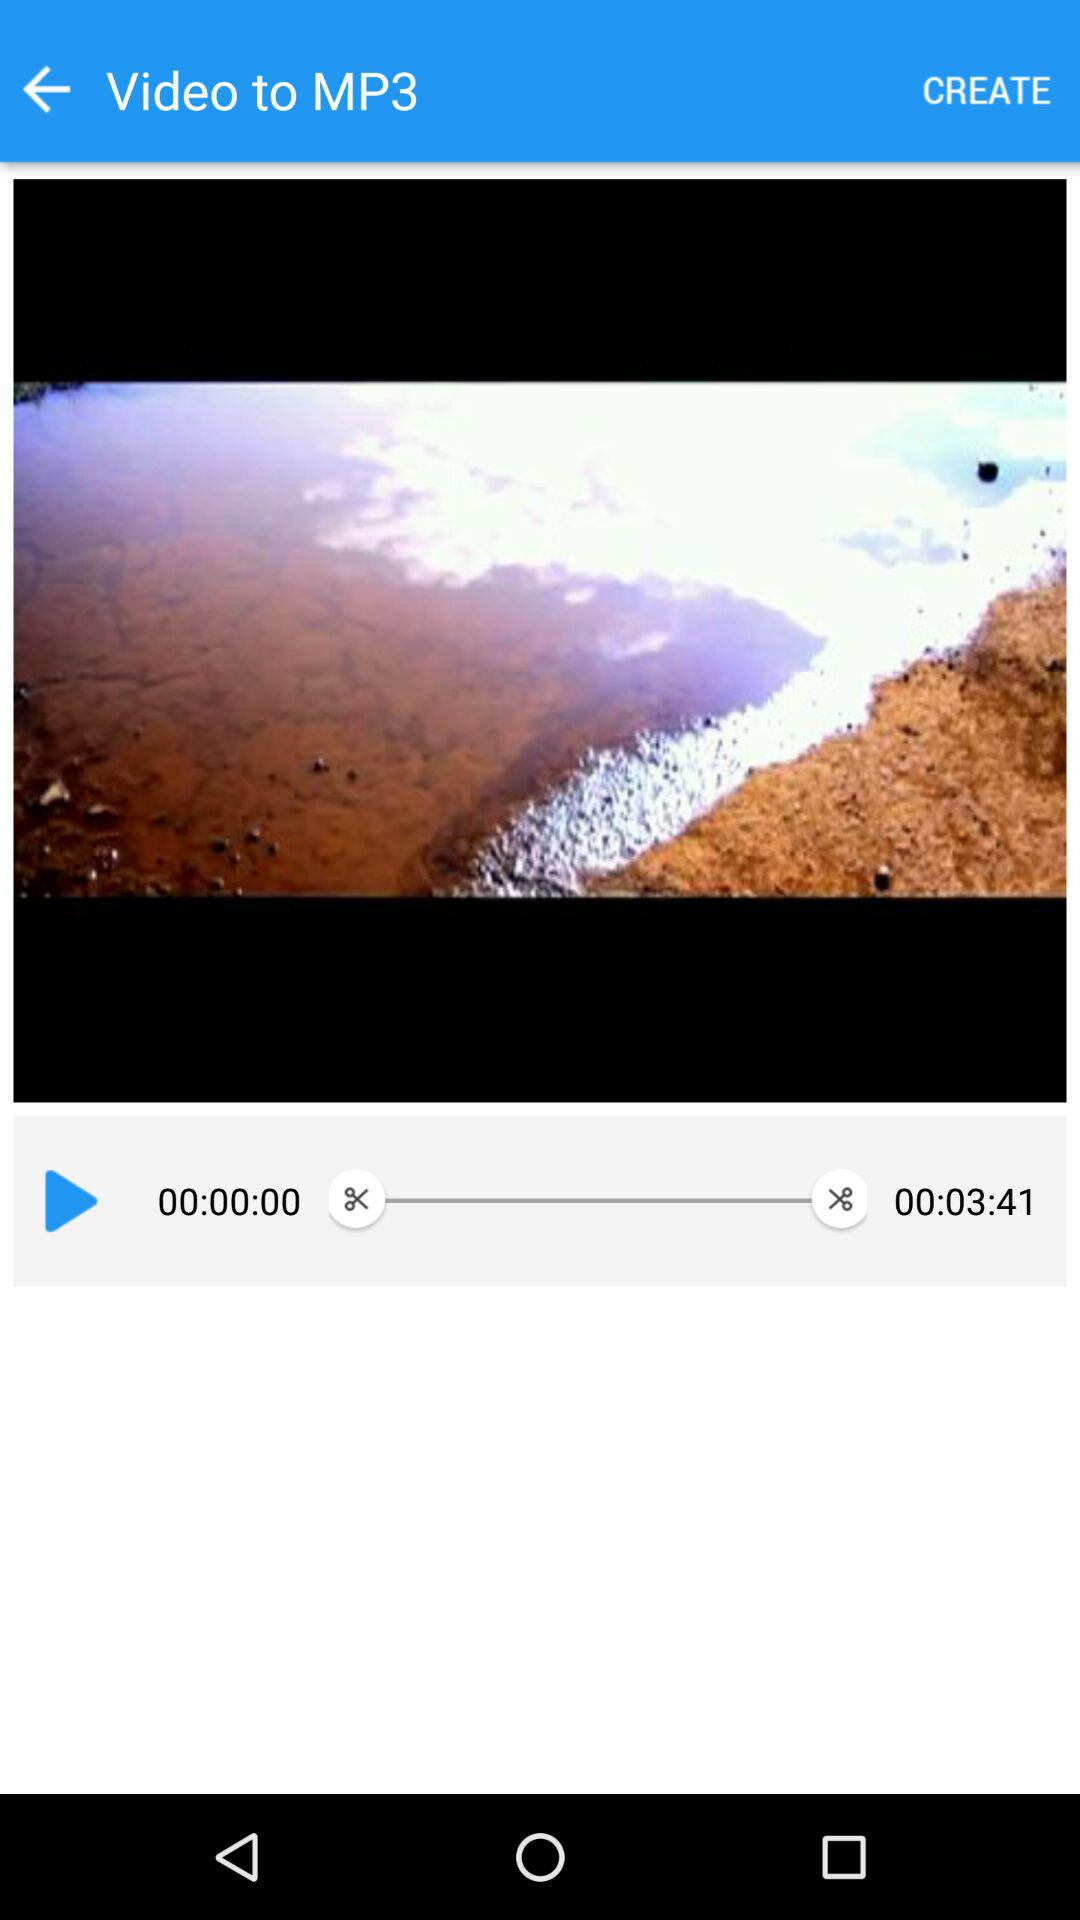How long is the video?
Answer the question using a single word or phrase. 00:03:41 